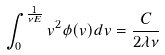Convert formula to latex. <formula><loc_0><loc_0><loc_500><loc_500>\int _ { 0 } ^ { \frac { 1 } { \nu E } } v ^ { 2 } \phi ( v ) d v = \frac { C } { 2 \lambda \nu }</formula> 